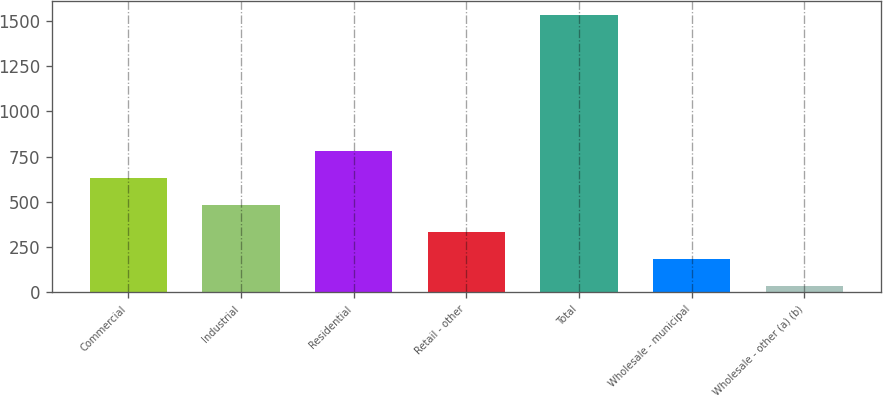Convert chart. <chart><loc_0><loc_0><loc_500><loc_500><bar_chart><fcel>Commercial<fcel>Industrial<fcel>Residential<fcel>Retail - other<fcel>Total<fcel>Wholesale - municipal<fcel>Wholesale - other (a) (b)<nl><fcel>633<fcel>483<fcel>783<fcel>333<fcel>1533<fcel>183<fcel>33<nl></chart> 